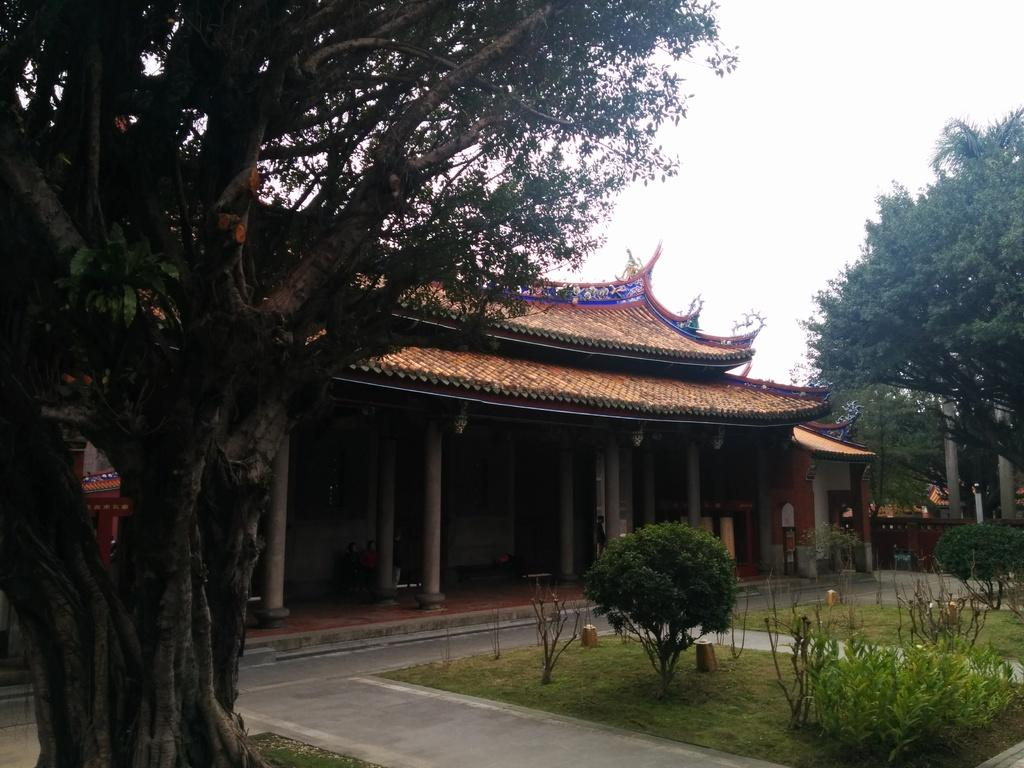What is located in the foreground of the image? There is a tree in the foreground of the image. What is the main structure in the center of the image? There is a house structure in the center of the image. What architectural elements can be seen in the center of the image? There are pillars in the center of the image. What types of vegetation are on the right side of the image? There are plants and trees on the right side of the image. What other objects are on the right side of the image? There are poles on the right side of the image. What can be seen in the background of the image? The sky is visible in the background of the image. What type of vegetable is growing on the tree in the image? There are no vegetables growing on the tree in the image; it is a tree with leaves and branches. How does the image twist the viewer's mind? The image does not twist the viewer's mind; it is a straightforward depiction of a tree, house structure, pillars, plants, trees, and poles. 